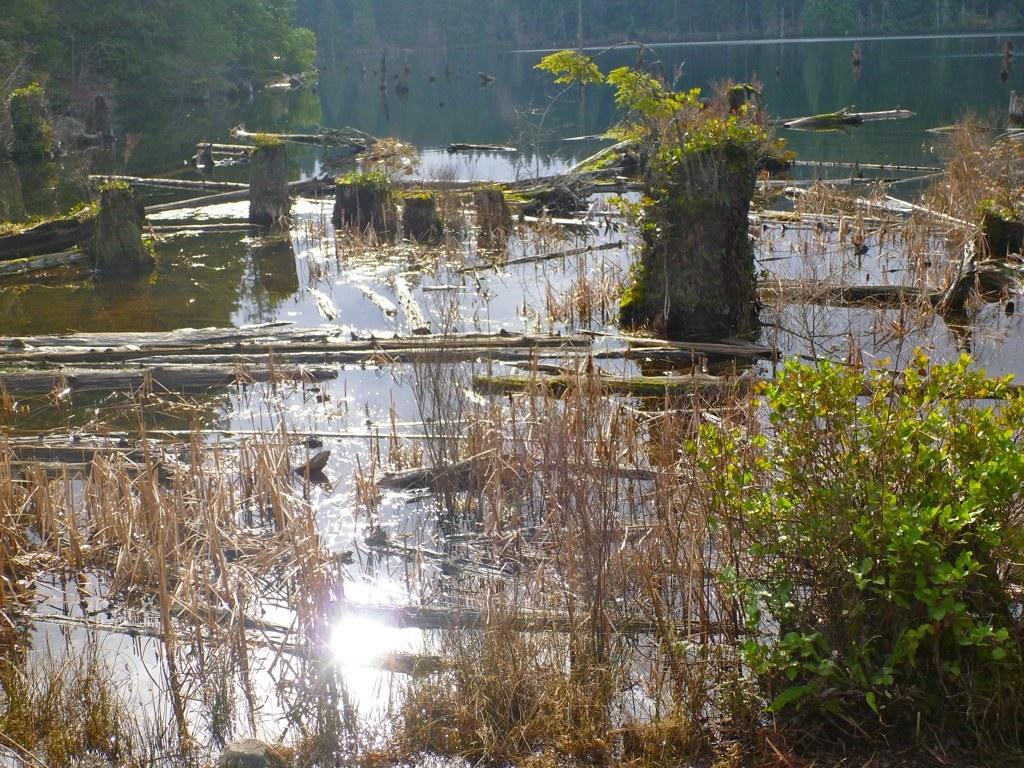What is the main subject in the center of the image? There is water in the center of the image. What type of vegetation can be seen in the image? There are plants and trees present in the image. What object is visible in the image that could be used for stirring or poking? A stick is present in the image. What type of ground cover is visible in the image? Grass is visible in the image. What type of impulse can be seen affecting the guitar in the image? There is no guitar present in the image, so it is not possible to determine if any impulse is affecting it. 